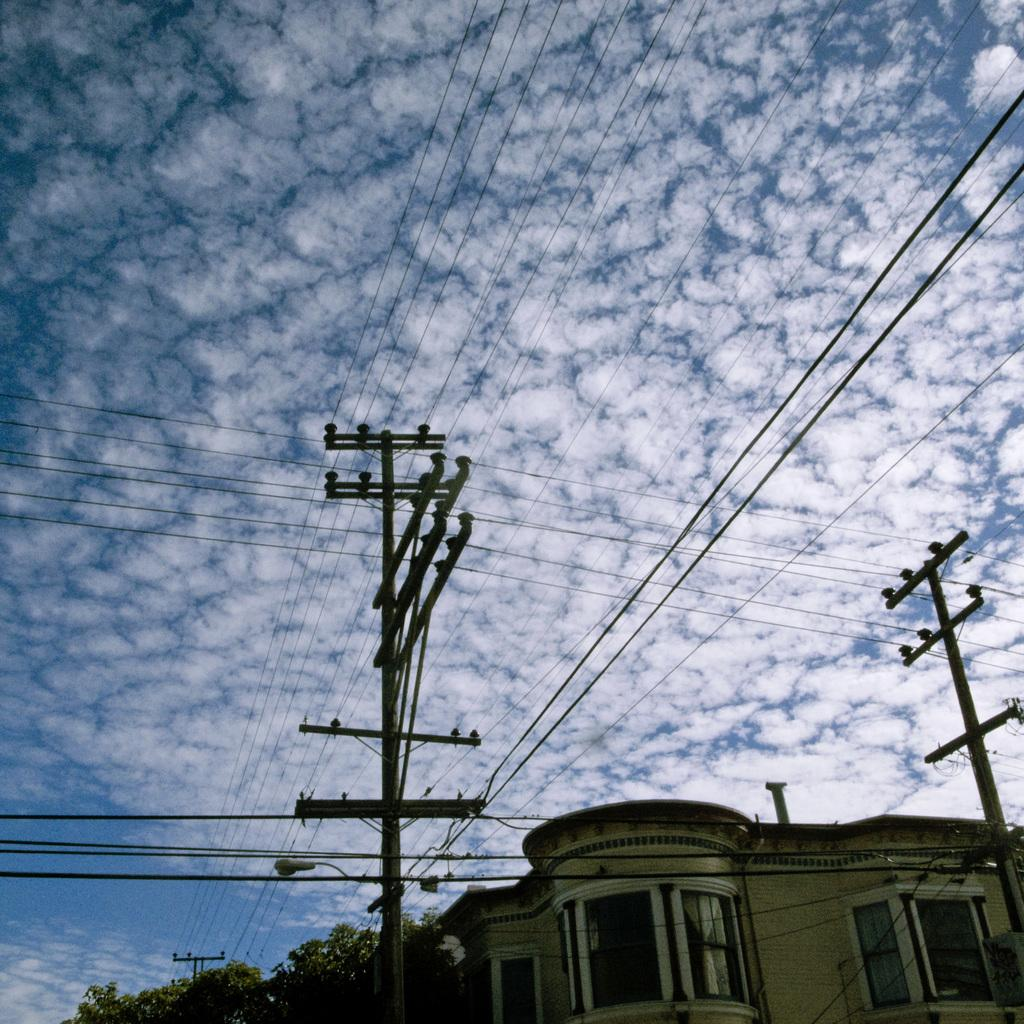What type of structure is present in the image? There is a building in the image. What feature can be seen on the building? The building has windows. What else can be seen in the image besides the building? There are electric poles, electric wires, trees, and a cloudy sky in the image. Can you see a fireman playing a guitar near the building in the image? No, there is no fireman or guitar present in the image. 